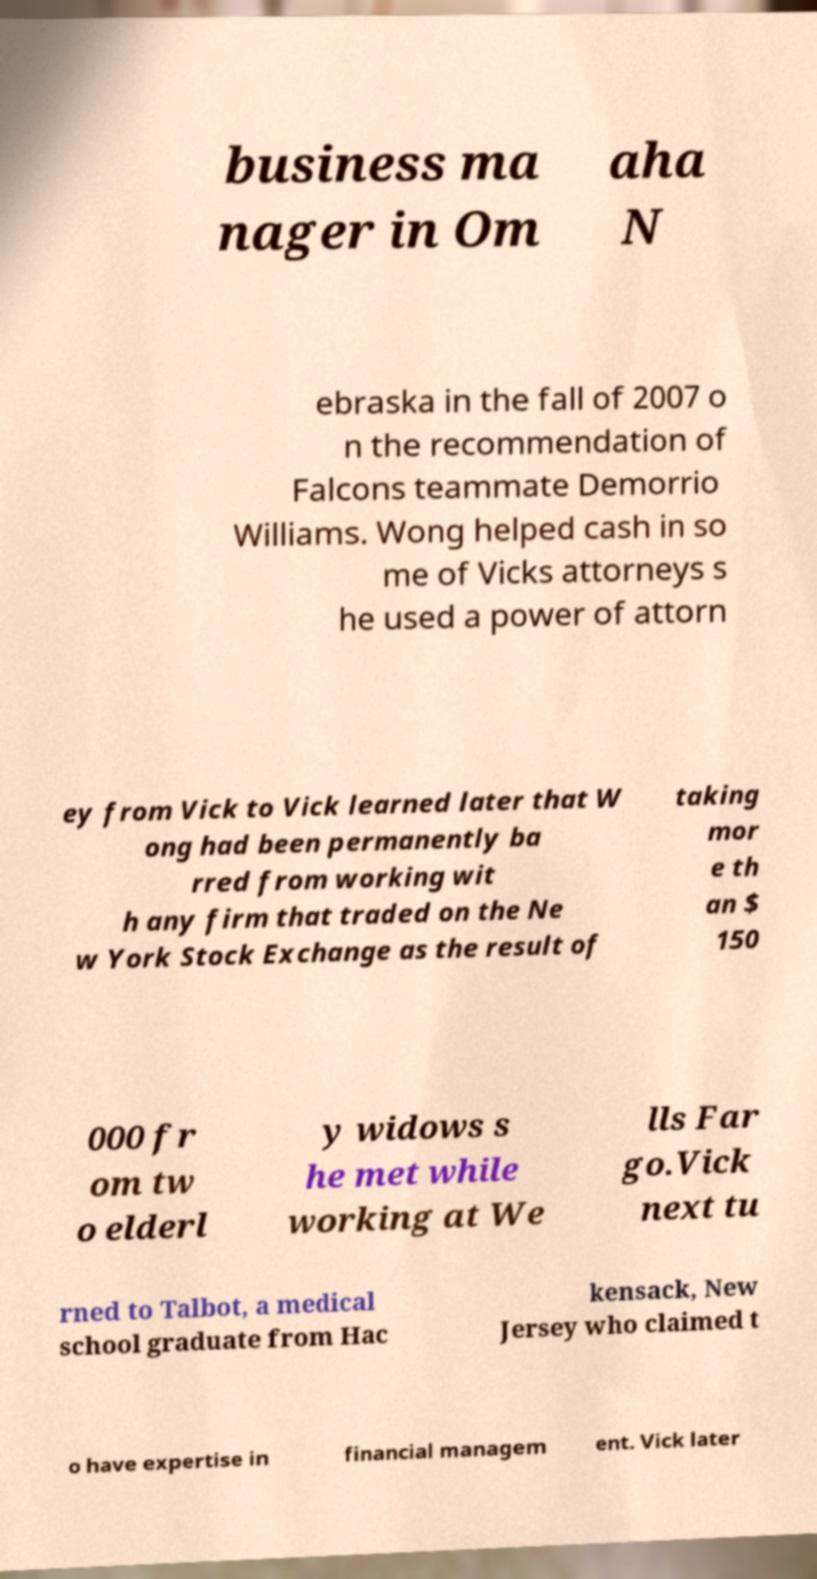Could you assist in decoding the text presented in this image and type it out clearly? business ma nager in Om aha N ebraska in the fall of 2007 o n the recommendation of Falcons teammate Demorrio Williams. Wong helped cash in so me of Vicks attorneys s he used a power of attorn ey from Vick to Vick learned later that W ong had been permanently ba rred from working wit h any firm that traded on the Ne w York Stock Exchange as the result of taking mor e th an $ 150 000 fr om tw o elderl y widows s he met while working at We lls Far go.Vick next tu rned to Talbot, a medical school graduate from Hac kensack, New Jersey who claimed t o have expertise in financial managem ent. Vick later 